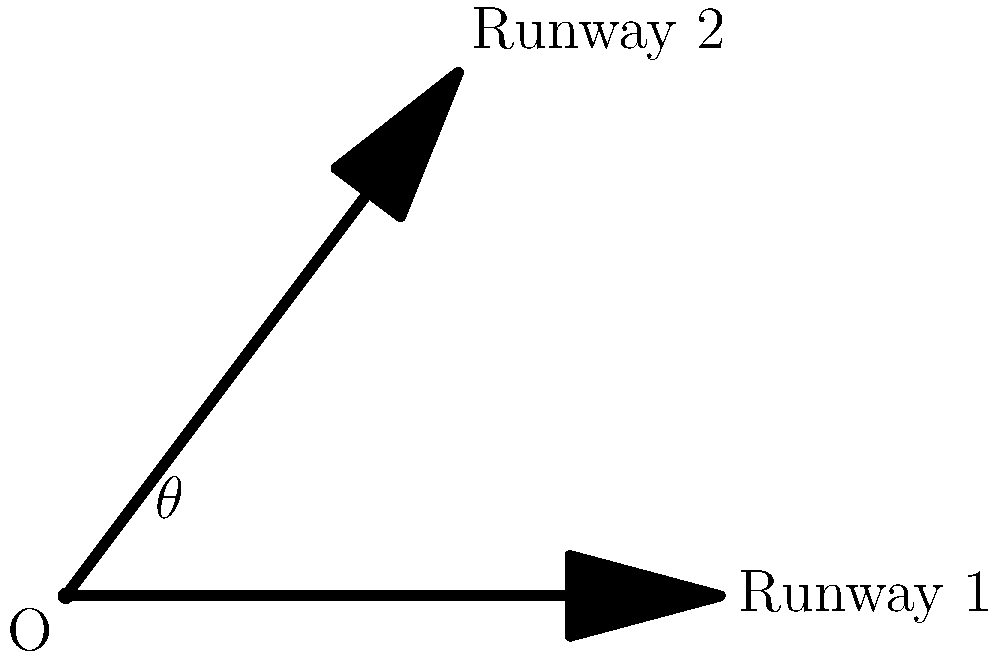Two runways intersect at point O as shown in the diagram. Runway 1 is represented by vector $\vec{a} = 5\hat{i}$, and Runway 2 is represented by vector $\vec{b} = 3\hat{i} + 4\hat{j}$. Calculate the angle $\theta$ between these two runways using vector operations. To find the angle between two vectors, we can use the dot product formula:

$$\cos \theta = \frac{\vec{a} \cdot \vec{b}}{|\vec{a}||\vec{b}|}$$

Step 1: Calculate the dot product $\vec{a} \cdot \vec{b}$
$\vec{a} \cdot \vec{b} = (5)(3) + (0)(4) = 15$

Step 2: Calculate the magnitudes of vectors $\vec{a}$ and $\vec{b}$
$|\vec{a}| = \sqrt{5^2 + 0^2} = 5$
$|\vec{b}| = \sqrt{3^2 + 4^2} = 5$

Step 3: Substitute into the dot product formula
$$\cos \theta = \frac{15}{(5)(5)} = \frac{15}{25} = 0.6$$

Step 4: Solve for $\theta$ using the inverse cosine function
$$\theta = \arccos(0.6) \approx 0.9273 \text{ radians}$$

Step 5: Convert radians to degrees
$$\theta \approx 0.9273 \times \frac{180^{\circ}}{\pi} \approx 53.13^{\circ}$$
Answer: $53.13^{\circ}$ 